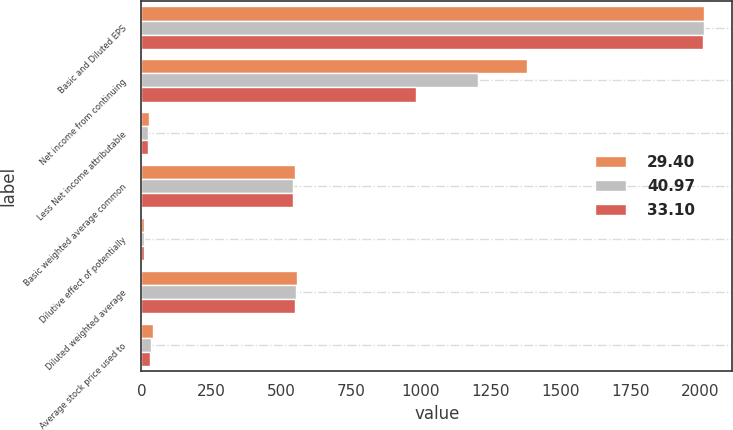Convert chart. <chart><loc_0><loc_0><loc_500><loc_500><stacked_bar_chart><ecel><fcel>Basic and Diluted EPS<fcel>Net income from continuing<fcel>Less Net income attributable<fcel>Basic weighted average common<fcel>Dilutive effect of potentially<fcel>Diluted weighted average<fcel>Average stock price used to<nl><fcel>29.4<fcel>2013<fcel>1379<fcel>28<fcel>549<fcel>9<fcel>558<fcel>40.97<nl><fcel>40.97<fcel>2012<fcel>1204<fcel>25<fcel>544<fcel>8<fcel>552<fcel>33.1<nl><fcel>33.1<fcel>2011<fcel>982<fcel>22<fcel>542<fcel>9<fcel>551<fcel>29.4<nl></chart> 